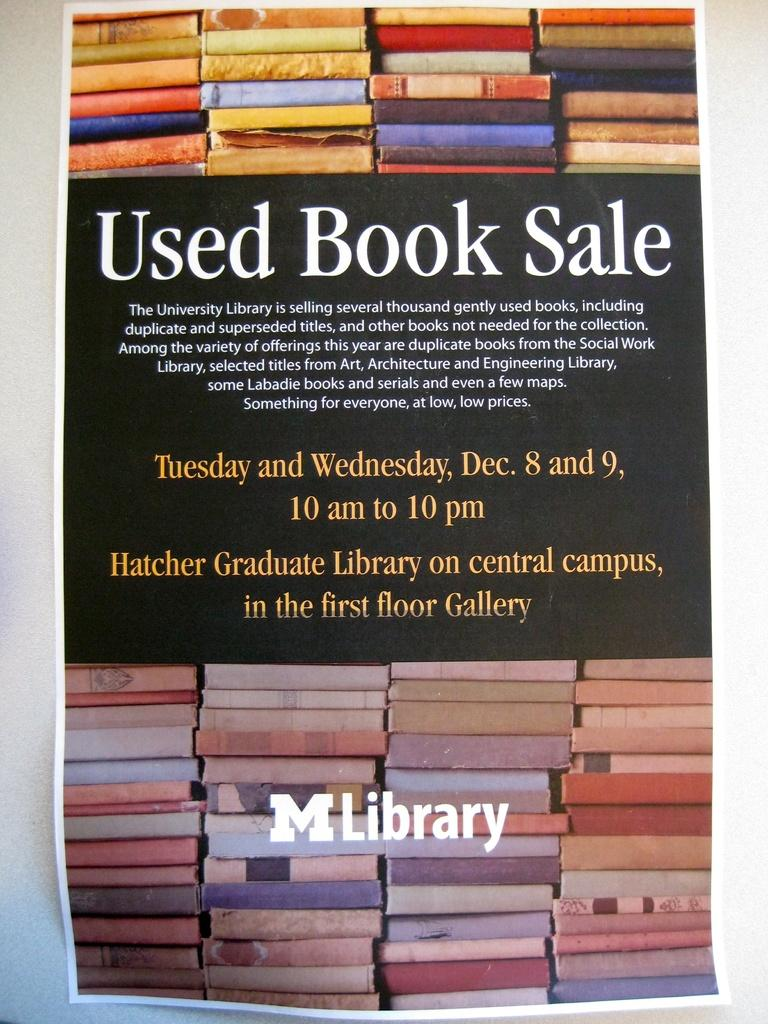<image>
Describe the image concisely. A flyer advertising a used book sale in December at a campus library 